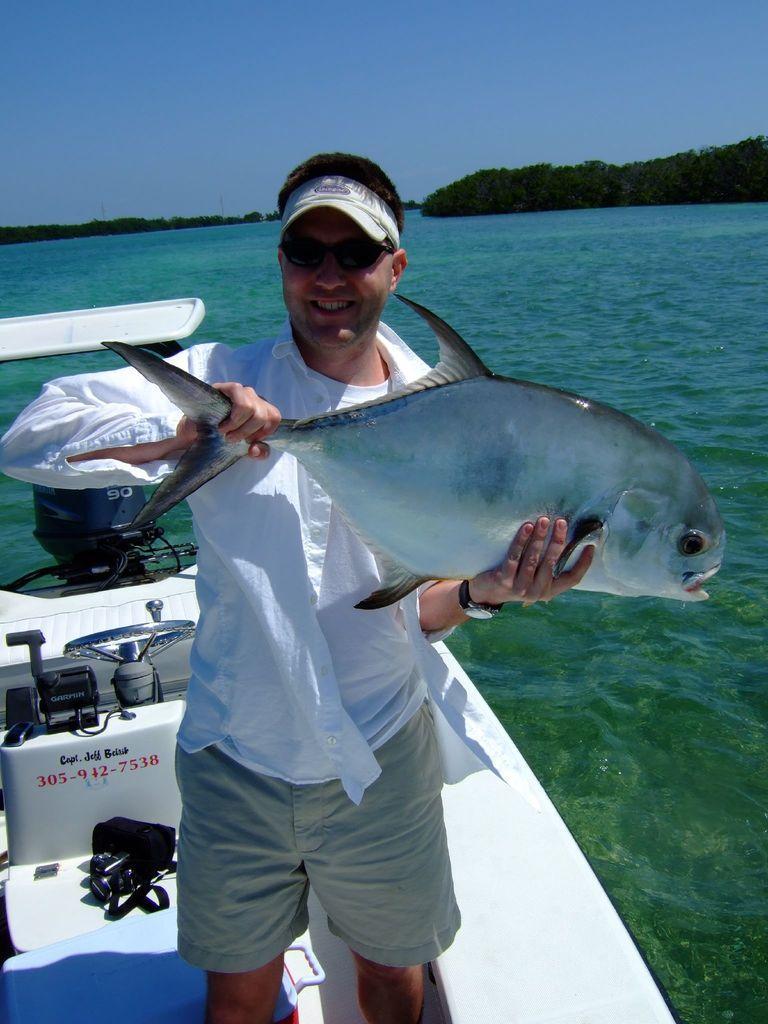How would you summarize this image in a sentence or two? In this picture we can see a man, standing in the front and holding the fish in the hand and giving a pose. Behind there is a white boat and sea water. In the background there are some trees. 